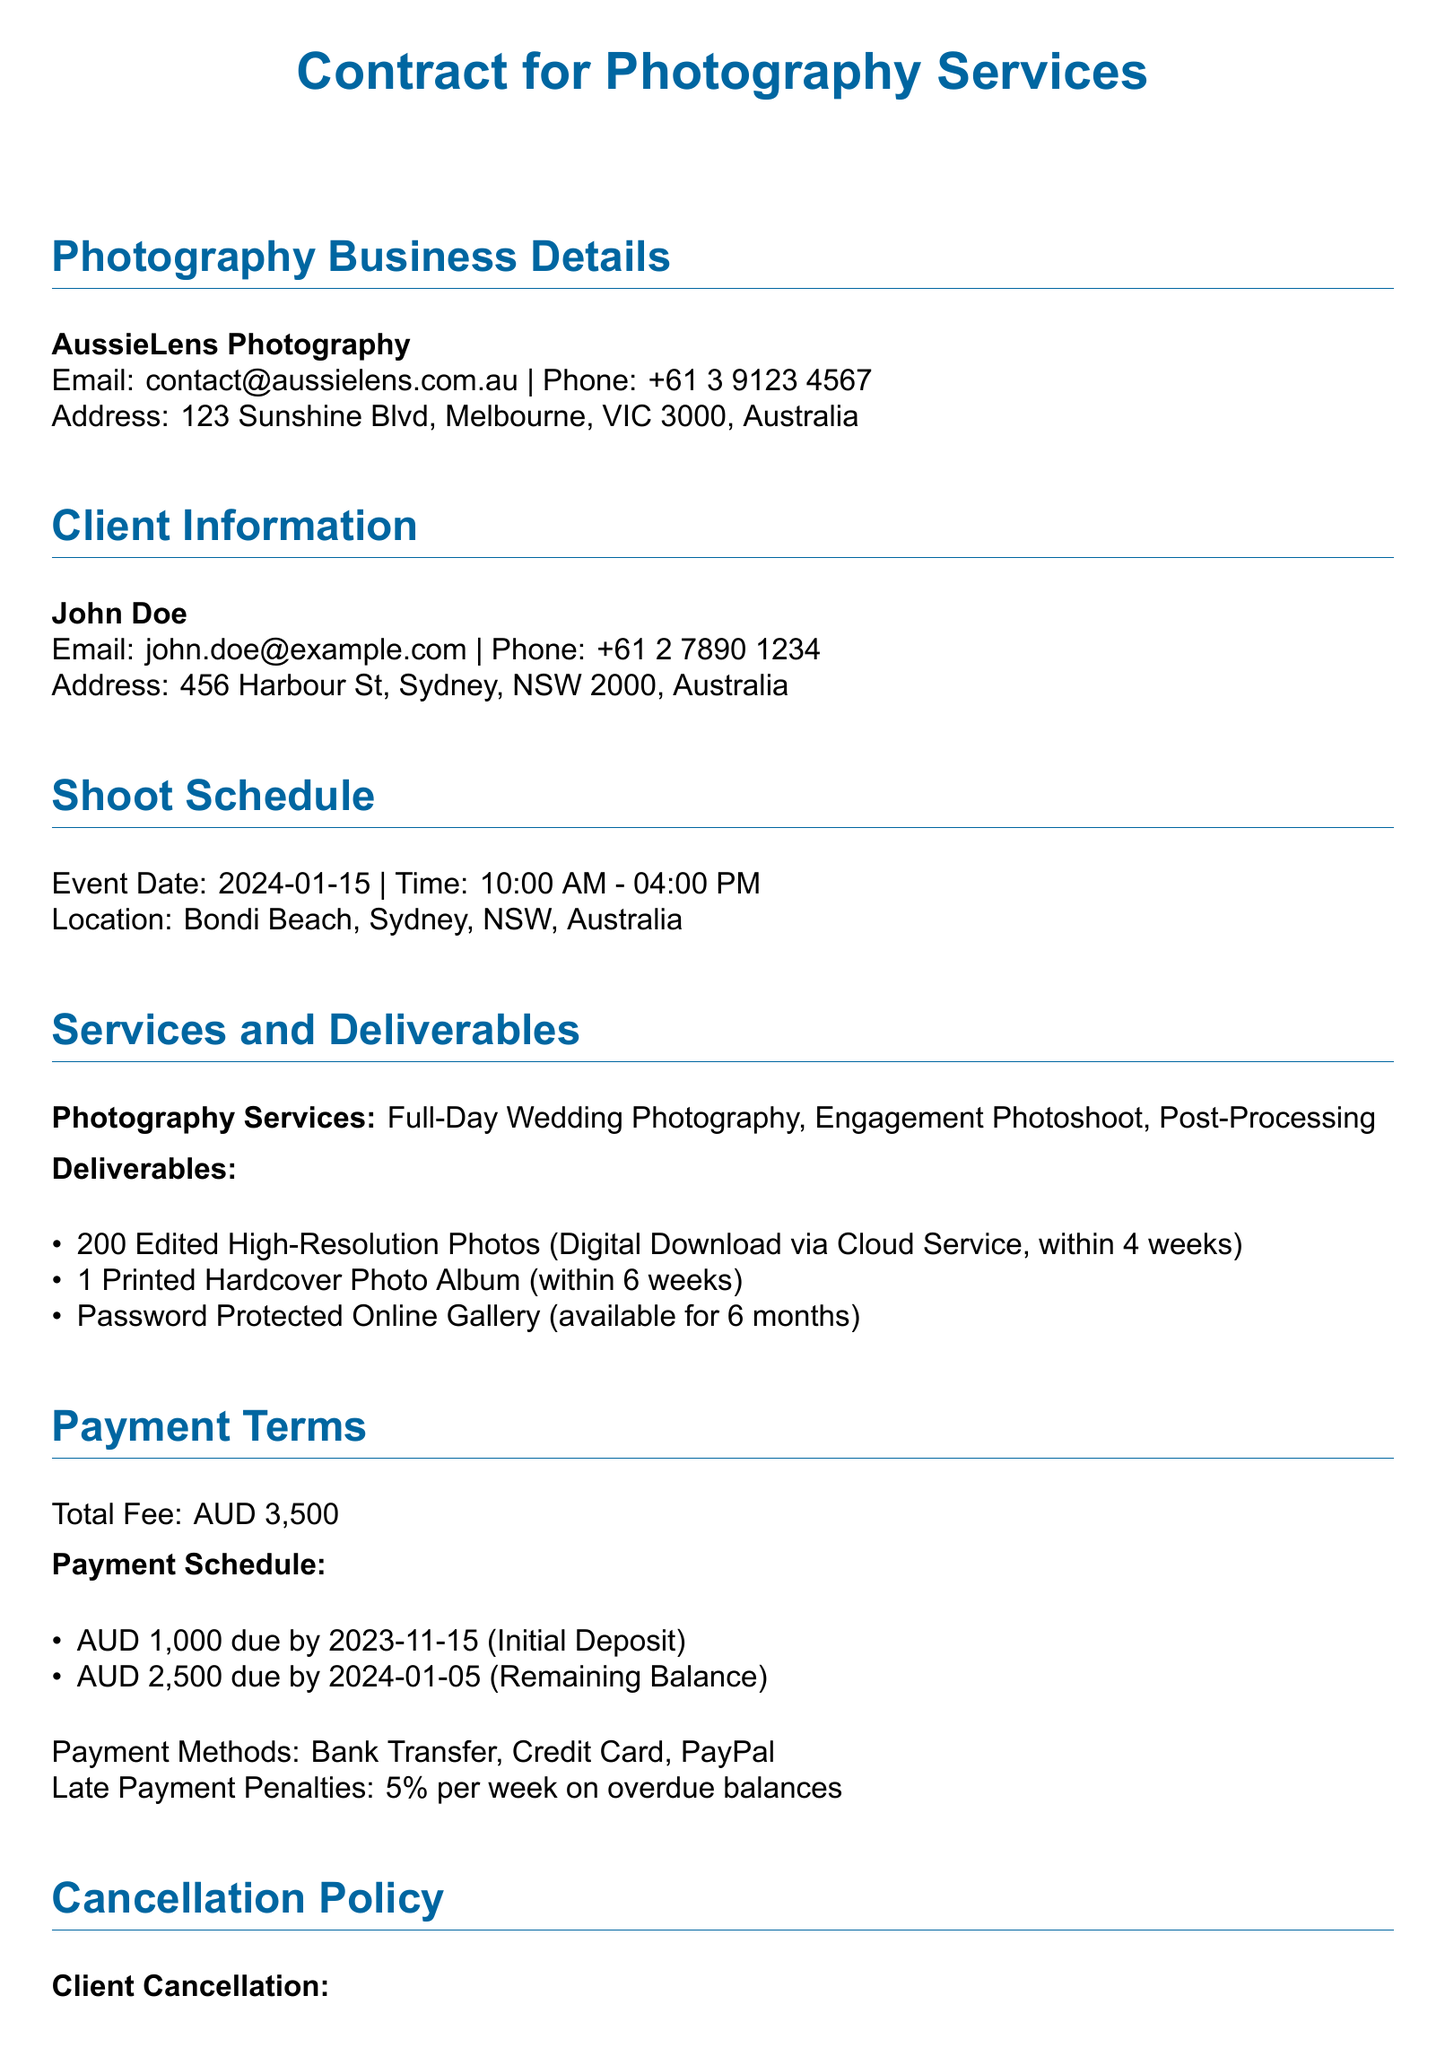What is the total fee for the photography services? The total fee is specified in the payment terms section of the document.
Answer: AUD 3,500 What is the date of the scheduled shoot? The shoot schedule section provides the exact date.
Answer: 2024-01-15 How many edited high-resolution photos will be delivered? The deliverables section lists the quantity of edited photos.
Answer: 200 Edited High-Resolution Photos What is the due date for the remaining balance? The payment schedule section specifies when the remaining balance is due.
Answer: 2024-01-05 What happens if the client cancels less than 30 days before the event? The cancellation policy outlines the terms for late cancellations.
Answer: No refund What is the payment method accepted? The payment terms section includes various payment methods.
Answer: Bank Transfer, Credit Card, PayPal How long will the online gallery be available? The deliverables section states the availability duration of the online gallery.
Answer: 6 months What is the initial deposit amount? The payment schedule lists the amount needed for the initial deposit.
Answer: AUD 1,000 What rights does the photographer have regarding the use of photos? The copyright and usage rights section describes the photographer's rights.
Answer: Right to use photos for portfolio and marketing 